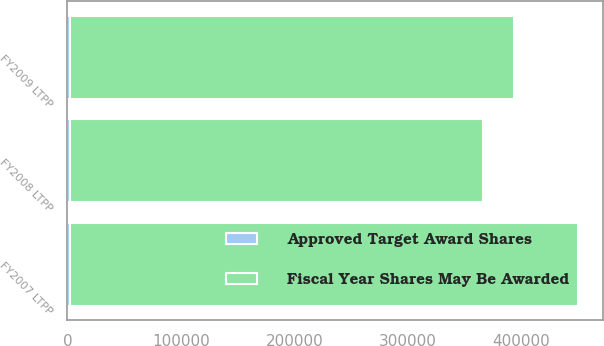<chart> <loc_0><loc_0><loc_500><loc_500><stacked_bar_chart><ecel><fcel>FY2007 LTPP<fcel>FY2008 LTPP<fcel>FY2009 LTPP<nl><fcel>Fiscal Year Shares May Be Awarded<fcel>447684<fcel>364396<fcel>391868<nl><fcel>Approved Target Award Shares<fcel>2010<fcel>2011<fcel>2012<nl></chart> 